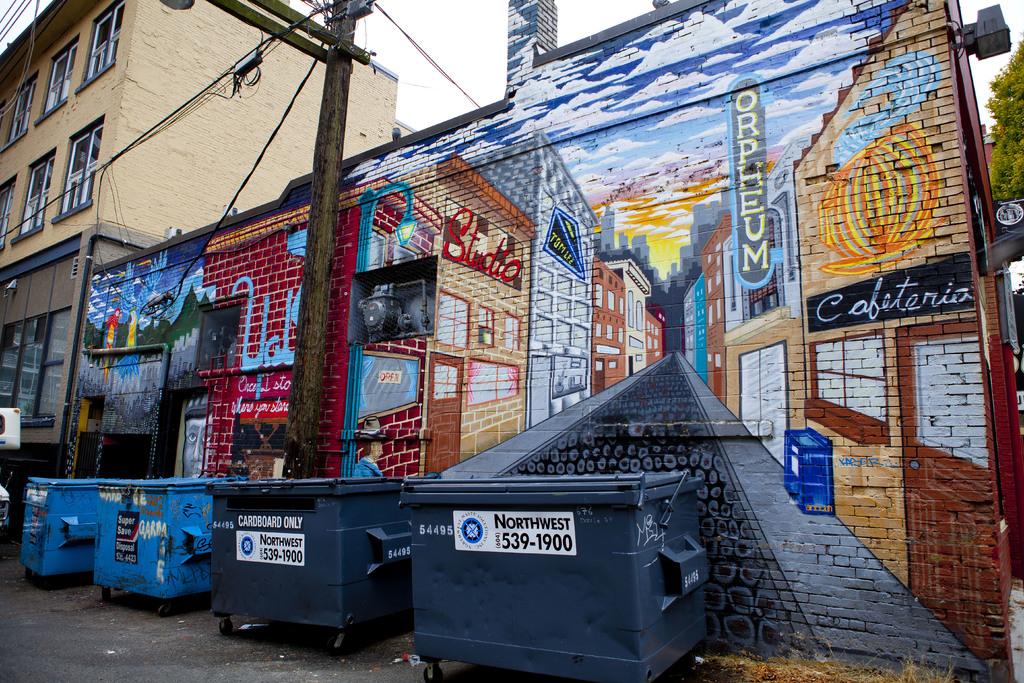What is inside the garbage can?
Offer a very short reply. Unanswerable. What phone number is for the garbage can?
Provide a succinct answer. 539-1900. 